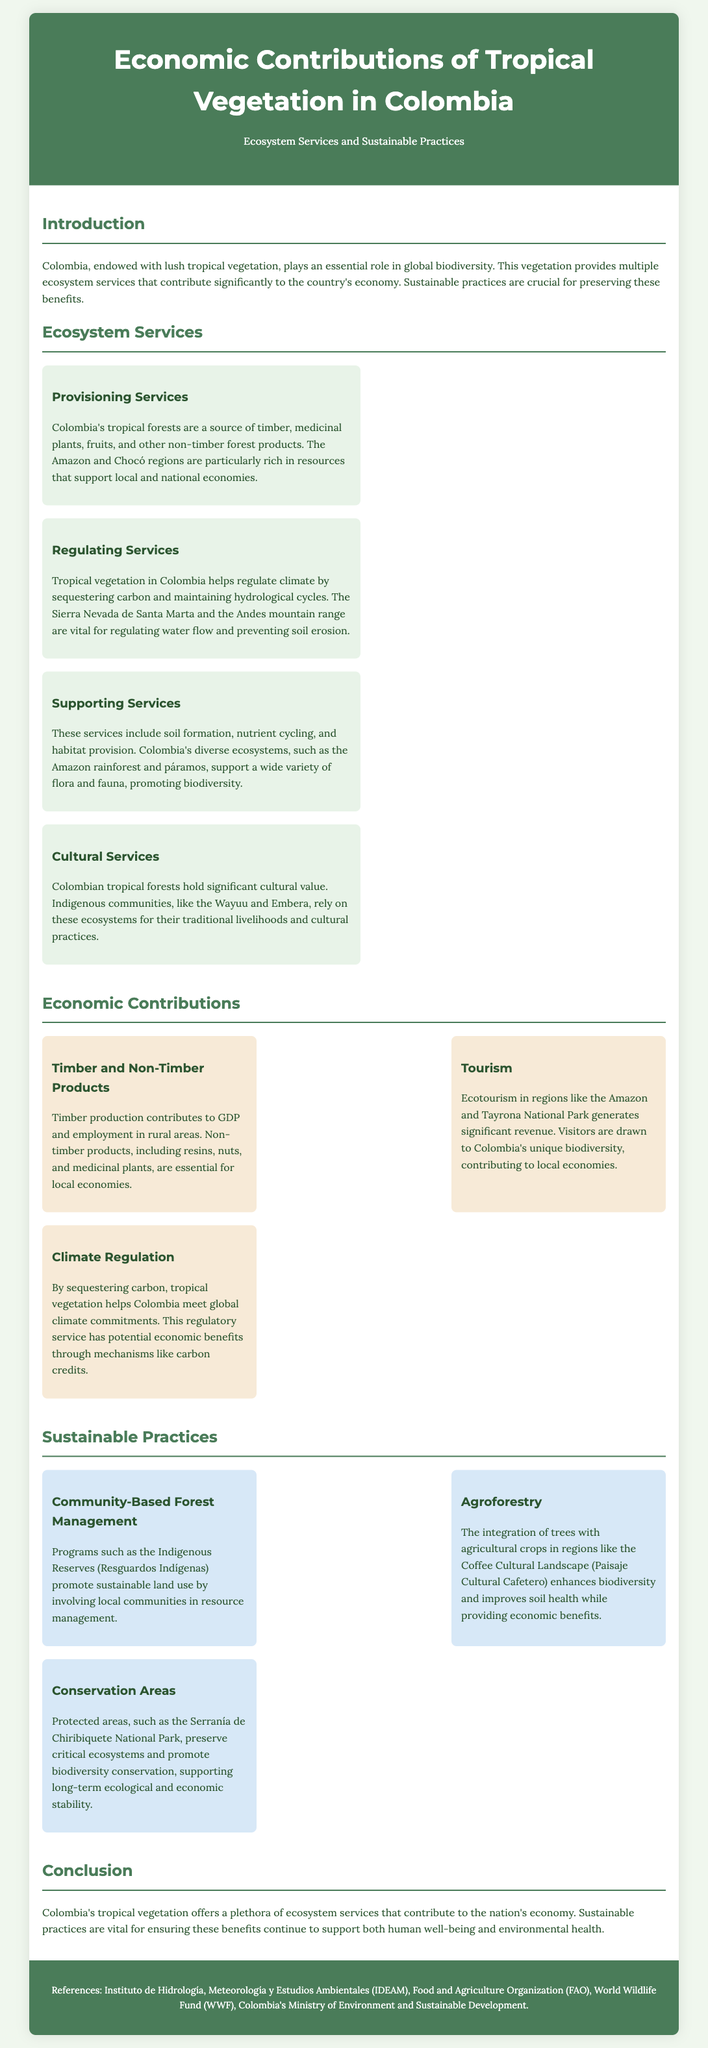What are provisioning services? Provisioning services refer to the resources provided by tropical forests, such as timber, medicinal plants, fruits, and non-timber forest products.
Answer: Timber, medicinal plants, fruits, non-timber forest products Which regions are particularly rich in resources? The document mentions the Amazon and Chocó regions as being particularly rich in resources.
Answer: Amazon and Chocó What is one of the cultural values of Colombian tropical forests? Indigenous communities, such as the Wayuu and Embera, rely on these ecosystems for their traditional livelihoods and cultural practices.
Answer: Traditional livelihoods and cultural practices How does tourism contribute to the economy? Ecotourism in regions like the Amazon and Tayrona National Park generates significant revenue from visitors attracted by biodiversity.
Answer: Significant revenue What role do protected areas play in sustainable practices? Protected areas preserve critical ecosystems and promote biodiversity conservation, supporting long-term ecological and economic stability.
Answer: Preserve critical ecosystems What major ecosystem service involves carbon sequestration? The regulatory service provided by tropical vegetation includes sequestering carbon to help meet global climate commitments.
Answer: Sequestering carbon What is a key sustainable practice mentioned in the document? Community-Based Forest Management is one of the sustainable practices promoted in the document to involve local communities in resource management.
Answer: Community-Based Forest Management What does agroforestry enhance? The integration of trees with agricultural crops enhances biodiversity and improves soil health while providing economic benefits.
Answer: Biodiversity and soil health 